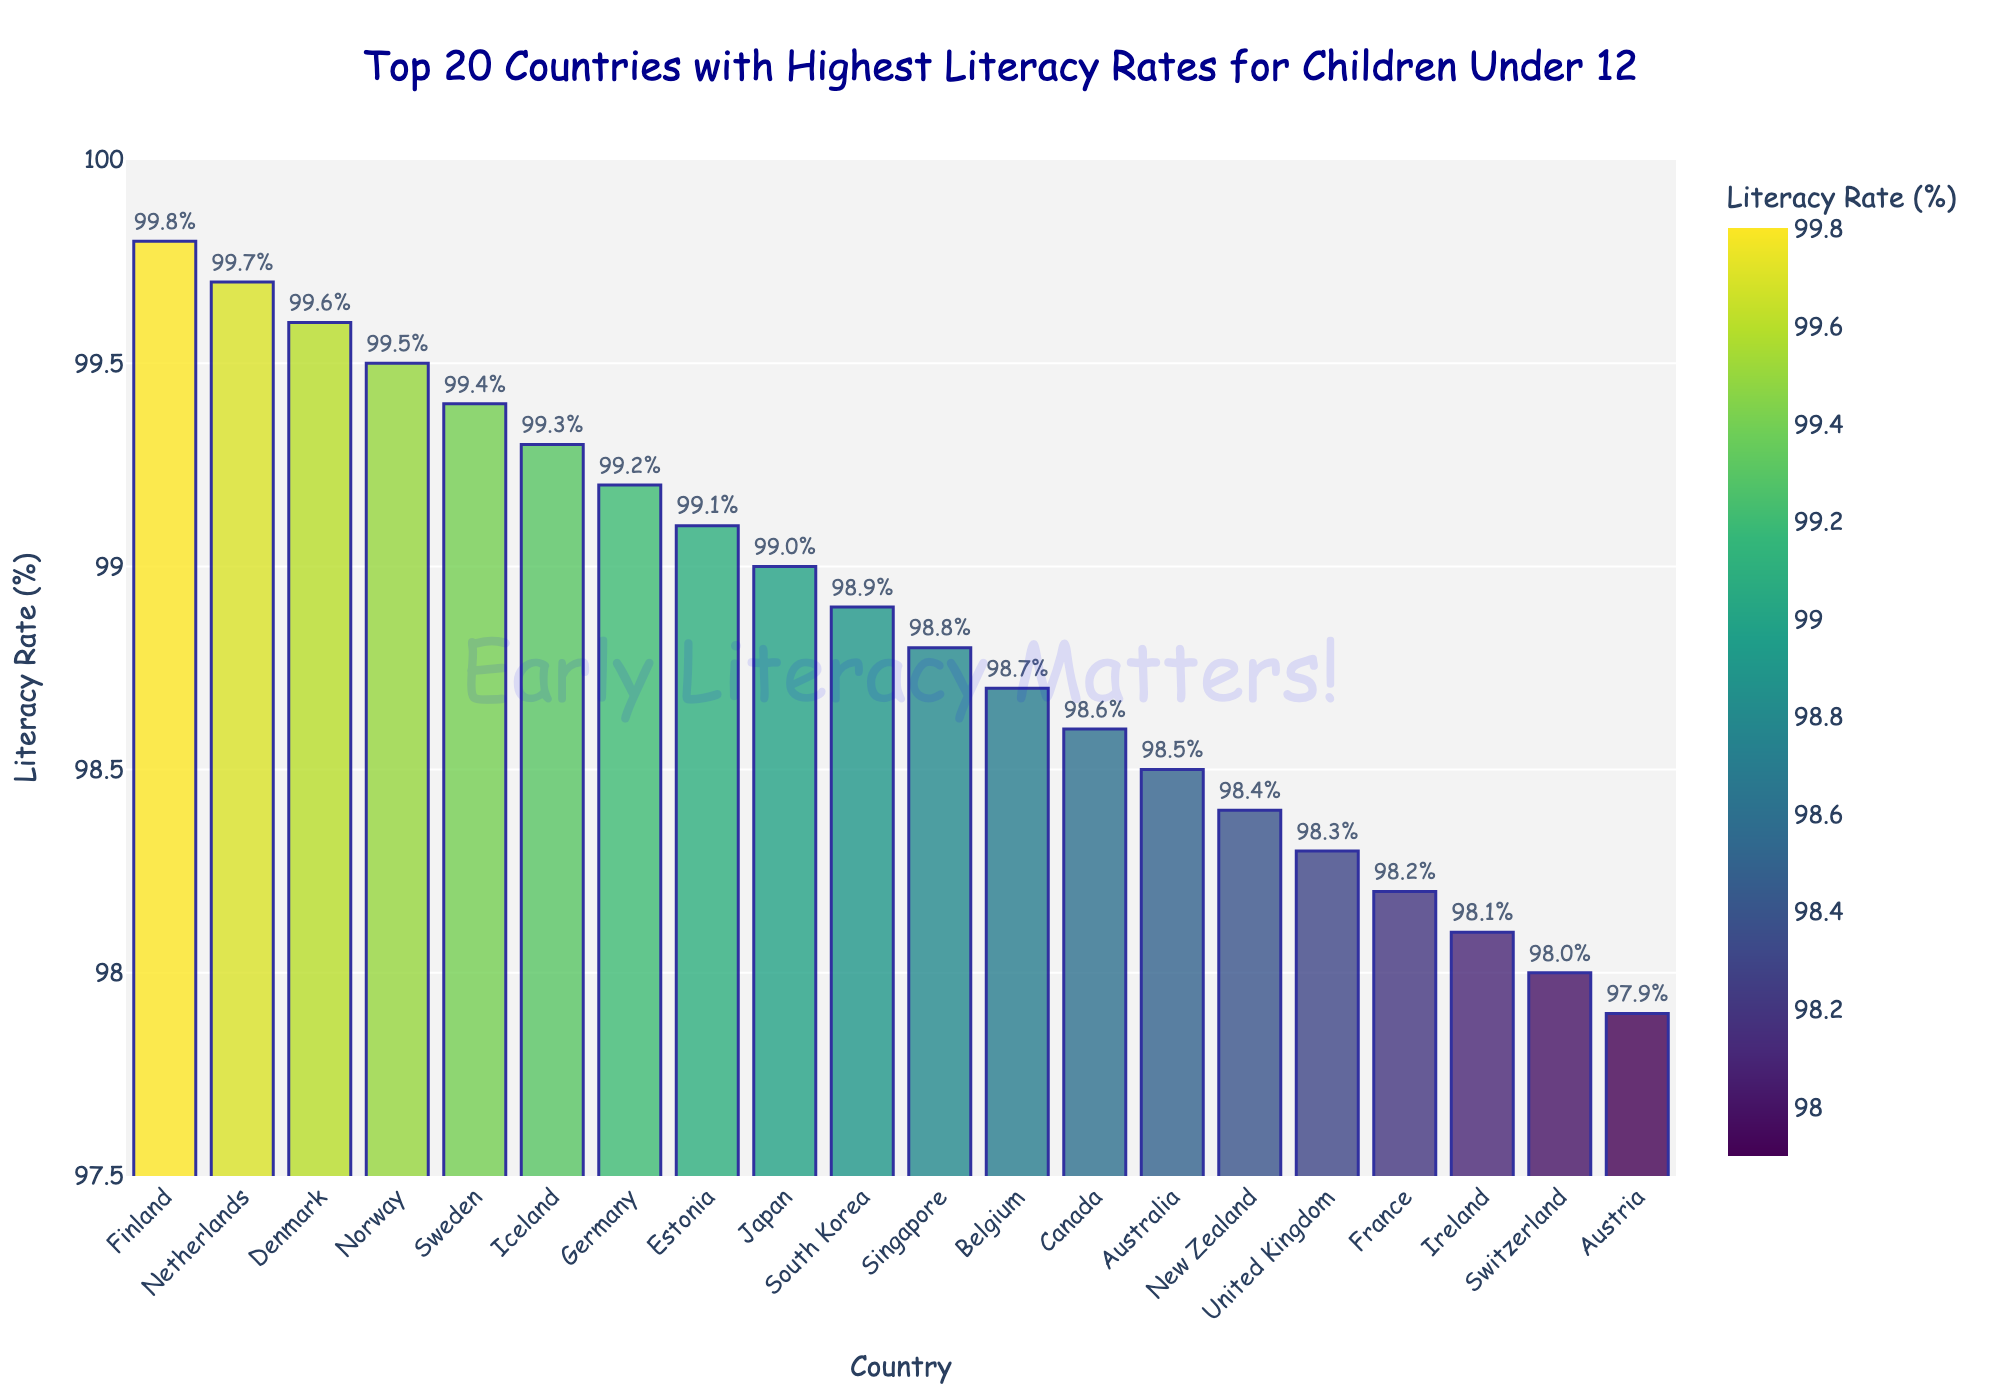Which country has the highest literacy rate for children under 12? The bar for Finland is the tallest and shows a literacy rate of 99.8%, indicating it has the highest literacy rate among the countries displayed.
Answer: Finland Which country has the lowest literacy rate for children under 12 in this top 20 list? The bar for Austria is the shortest and shows a literacy rate of 97.9%, indicating it has the lowest literacy rate among the countries displayed.
Answer: Austria What is the difference in literacy rates between the highest and lowest countries? The highest literacy rate is 99.8% (Finland) and the lowest is 97.9% (Austria). The difference is 99.8 - 97.9 = 1.9%.
Answer: 1.9% Which countries have literacy rates equal to or higher than 99%? The bars representing Finland, Netherlands, Denmark, Norway, Sweden, Iceland, Germany, and Estonia all reach or exceed the 99% mark on the y-axis.
Answer: Finland, Netherlands, Denmark, Norway, Sweden, Iceland, Germany, Estonia What is the average literacy rate of the top 5 countries? The literacy rates for the top 5 countries are Finland (99.8%), Netherlands (99.7%), Denmark (99.6%), Norway (99.5%), and Sweden (99.4%). The sum is 99.8 + 99.7 + 99.6 + 99.5 + 99.4 = 497.9. The average is 497.9 / 5 = 99.58%.
Answer: 99.58% How many countries have literacy rates between 98.0% and 99.0%? The countries falling within this range are Japan (99.0%), South Korea (98.9%), Singapore (98.8%), Belgium (98.7%), Canada (98.6%), Australia (98.5%), New Zealand (98.4%), and United Kingdom (98.3%), France (98.2%), and Ireland (98.1%), Switzerland (98.0%). Count the bars corresponding to these countries in that range.
Answer: 11 What is the cumulative literacy rate for the top 3 countries combined? The literacy rates for the top 3 countries are Finland (99.8%), Netherlands (99.7%), and Denmark (99.6%). The sum is 99.8 + 99.7 + 99.6 = 299.1%.
Answer: 299.1% Which countries have literacy rates that are visually distinct in height compared to Australia? Australia's literacy rate is 98.5%. The countries with notably higher rates include Finland, Netherlands, Denmark, Norway, Sweden, Iceland, Germany, Estonia, Japan, South Korea, and Singapore, where their heights exceed Australia's.
Answer: Finland, Netherlands, Denmark, Norway, Sweden, Iceland, Germany, Estonia, Japan, South Korea, Singapore 